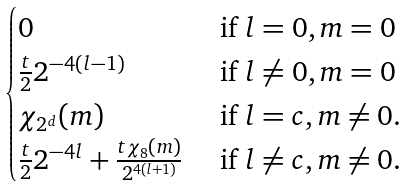<formula> <loc_0><loc_0><loc_500><loc_500>\begin{cases} 0 & \text { if $l=0,m=0$} \\ \frac { t } { 2 } 2 ^ { - 4 ( l - 1 ) } & \text { if $l\neq 0, m=0$} \\ \chi _ { 2 ^ { d } } ( m ) & \text { if $l=c, m\neq 0$. } \\ \frac { t } { 2 } 2 ^ { - 4 l } + \frac { t \chi _ { 8 } ( m ) } { 2 ^ { 4 ( l + 1 ) } } & \text { if $l\neq c,m\neq 0$. } \end{cases}</formula> 